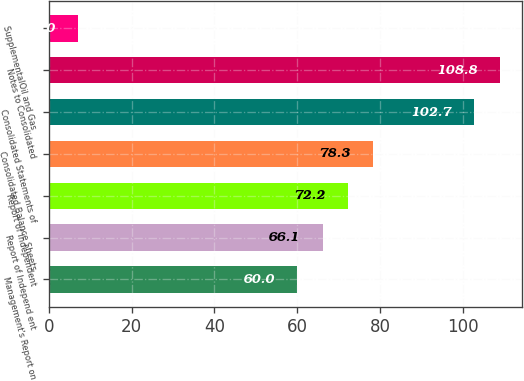<chart> <loc_0><loc_0><loc_500><loc_500><bar_chart><fcel>Management's Report on<fcel>Report of Independ ent<fcel>Report of Independent<fcel>Consolidated Balance Sheets<fcel>Consolidated Statements of<fcel>Notes to Consolidated<fcel>SupplementalOil and Gas<nl><fcel>60<fcel>66.1<fcel>72.2<fcel>78.3<fcel>102.7<fcel>108.8<fcel>7<nl></chart> 